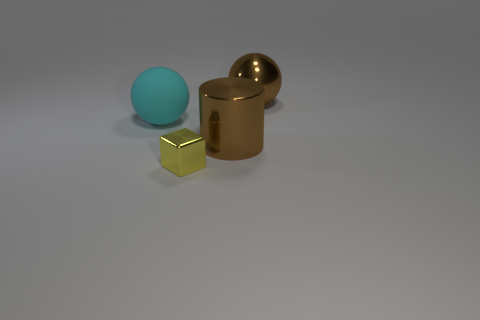Add 1 small gray objects. How many objects exist? 5 Subtract all blocks. How many objects are left? 3 Subtract 0 purple blocks. How many objects are left? 4 Subtract all shiny things. Subtract all tiny gray blocks. How many objects are left? 1 Add 3 cyan matte things. How many cyan matte things are left? 4 Add 4 big balls. How many big balls exist? 6 